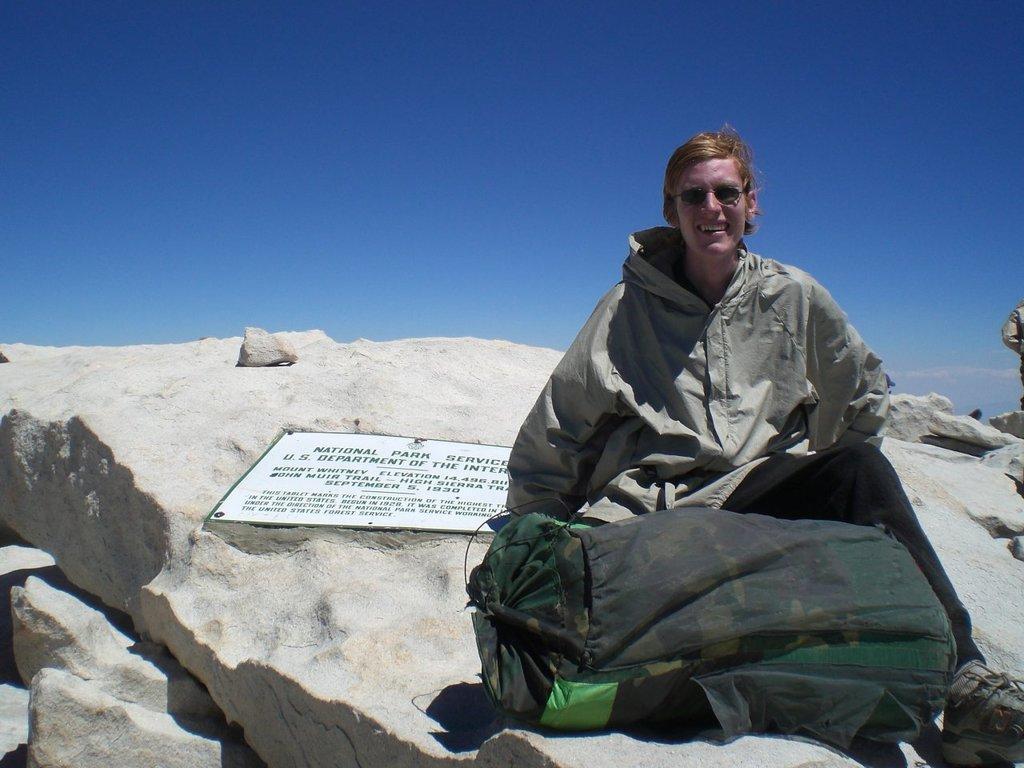Please provide a concise description of this image. In this image there is one person who is sitting and in front of him there is one bag, and in the background there are some rocks and on the rocks there is one board. On the board there is some text, and at the top of the image there is sky. 